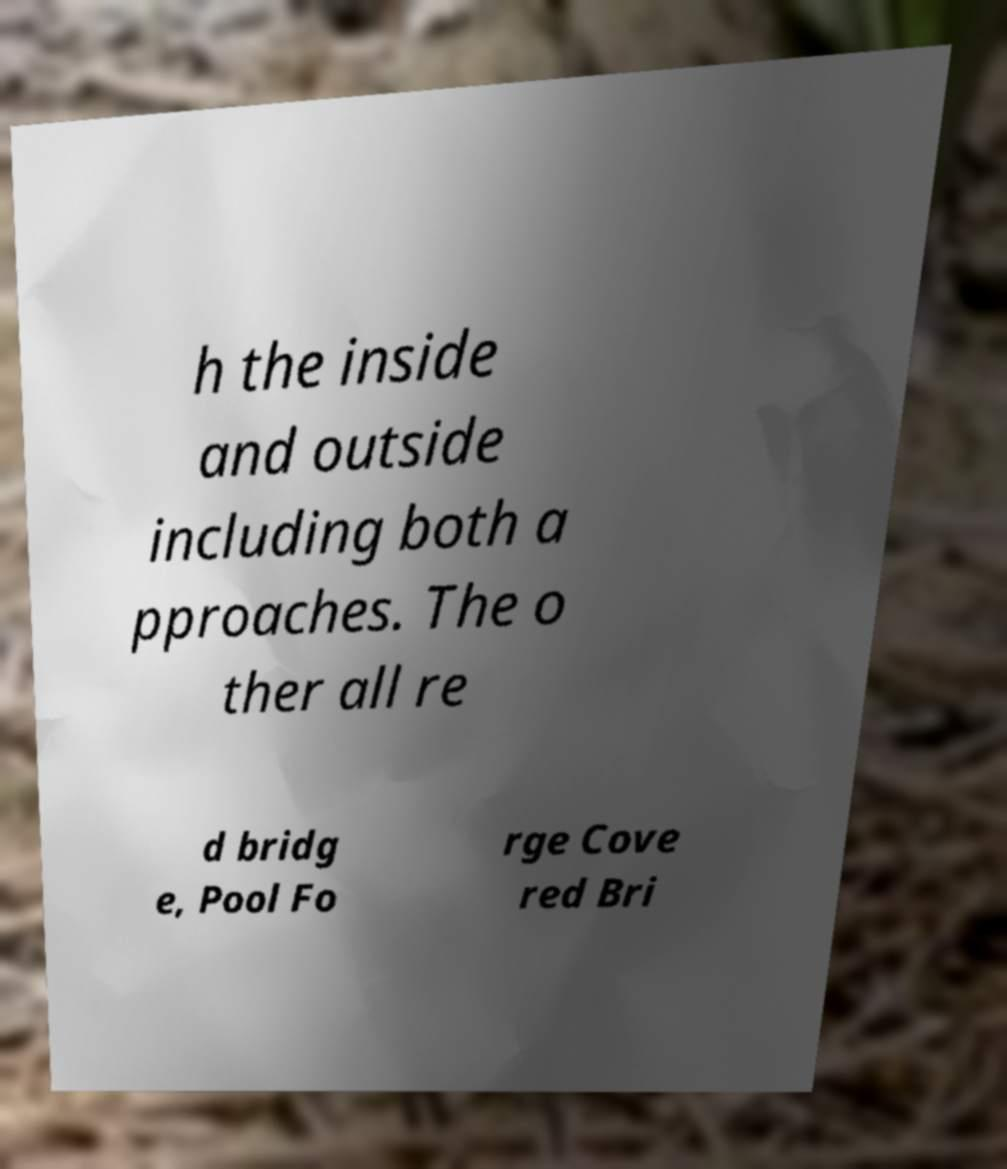Could you extract and type out the text from this image? h the inside and outside including both a pproaches. The o ther all re d bridg e, Pool Fo rge Cove red Bri 